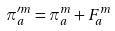<formula> <loc_0><loc_0><loc_500><loc_500>\pi ^ { \prime m } _ { a } = \pi ^ { m } _ { a } + F ^ { m } _ { a }</formula> 